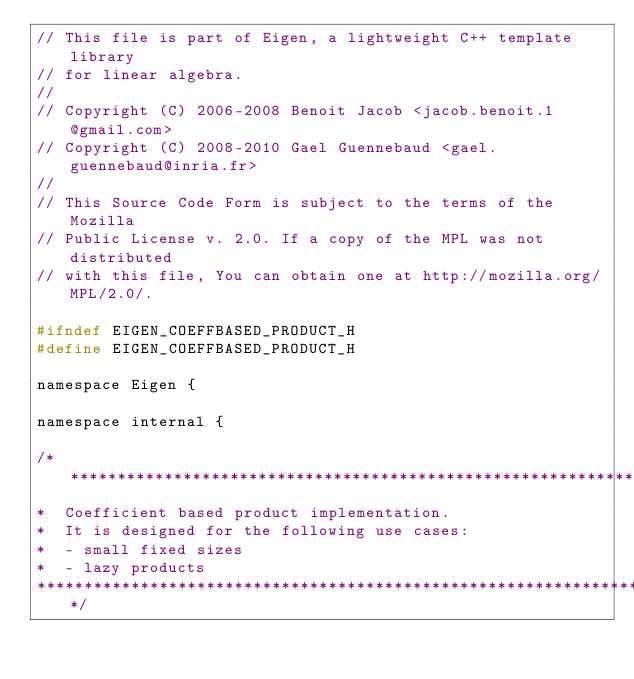Convert code to text. <code><loc_0><loc_0><loc_500><loc_500><_C_>// This file is part of Eigen, a lightweight C++ template library
// for linear algebra.
//
// Copyright (C) 2006-2008 Benoit Jacob <jacob.benoit.1@gmail.com>
// Copyright (C) 2008-2010 Gael Guennebaud <gael.guennebaud@inria.fr>
//
// This Source Code Form is subject to the terms of the Mozilla
// Public License v. 2.0. If a copy of the MPL was not distributed
// with this file, You can obtain one at http://mozilla.org/MPL/2.0/.

#ifndef EIGEN_COEFFBASED_PRODUCT_H
#define EIGEN_COEFFBASED_PRODUCT_H

namespace Eigen { 

namespace internal {

/*********************************************************************************
*  Coefficient based product implementation.
*  It is designed for the following use cases:
*  - small fixed sizes
*  - lazy products
*********************************************************************************/
</code> 